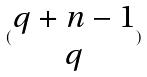Convert formula to latex. <formula><loc_0><loc_0><loc_500><loc_500>( \begin{matrix} q + n - 1 \\ q \end{matrix} )</formula> 